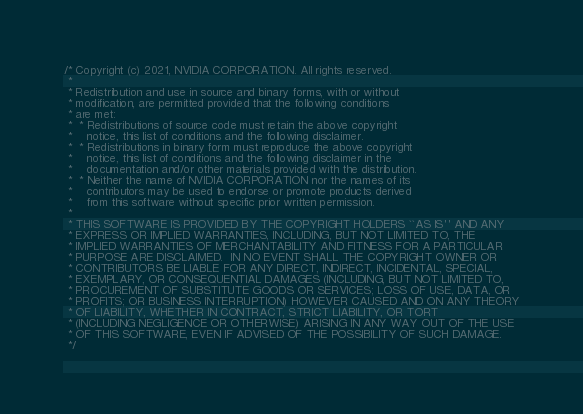Convert code to text. <code><loc_0><loc_0><loc_500><loc_500><_Cuda_>/* Copyright (c) 2021, NVIDIA CORPORATION. All rights reserved.
 *
 * Redistribution and use in source and binary forms, with or without
 * modification, are permitted provided that the following conditions
 * are met:
 *  * Redistributions of source code must retain the above copyright
 *    notice, this list of conditions and the following disclaimer.
 *  * Redistributions in binary form must reproduce the above copyright
 *    notice, this list of conditions and the following disclaimer in the
 *    documentation and/or other materials provided with the distribution.
 *  * Neither the name of NVIDIA CORPORATION nor the names of its
 *    contributors may be used to endorse or promote products derived
 *    from this software without specific prior written permission.
 *
 * THIS SOFTWARE IS PROVIDED BY THE COPYRIGHT HOLDERS ``AS IS'' AND ANY
 * EXPRESS OR IMPLIED WARRANTIES, INCLUDING, BUT NOT LIMITED TO, THE
 * IMPLIED WARRANTIES OF MERCHANTABILITY AND FITNESS FOR A PARTICULAR
 * PURPOSE ARE DISCLAIMED.  IN NO EVENT SHALL THE COPYRIGHT OWNER OR
 * CONTRIBUTORS BE LIABLE FOR ANY DIRECT, INDIRECT, INCIDENTAL, SPECIAL,
 * EXEMPLARY, OR CONSEQUENTIAL DAMAGES (INCLUDING, BUT NOT LIMITED TO,
 * PROCUREMENT OF SUBSTITUTE GOODS OR SERVICES; LOSS OF USE, DATA, OR
 * PROFITS; OR BUSINESS INTERRUPTION) HOWEVER CAUSED AND ON ANY THEORY
 * OF LIABILITY, WHETHER IN CONTRACT, STRICT LIABILITY, OR TORT
 * (INCLUDING NEGLIGENCE OR OTHERWISE) ARISING IN ANY WAY OUT OF THE USE
 * OF THIS SOFTWARE, EVEN IF ADVISED OF THE POSSIBILITY OF SUCH DAMAGE.
 */
</code> 